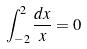Convert formula to latex. <formula><loc_0><loc_0><loc_500><loc_500>\int _ { - 2 } ^ { 2 } \frac { d x } { x } = 0</formula> 